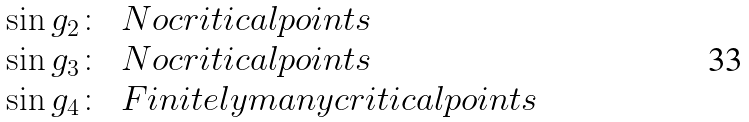Convert formula to latex. <formula><loc_0><loc_0><loc_500><loc_500>\begin{array} { c l } \sin g _ { 2 } \colon & N o c r i t i c a l p o i n t s \\ \sin g _ { 3 } \colon & N o c r i t i c a l p o i n t s \\ \sin g _ { 4 } \colon & F i n i t e l y m a n y c r i t i c a l p o i n t s \end{array}</formula> 